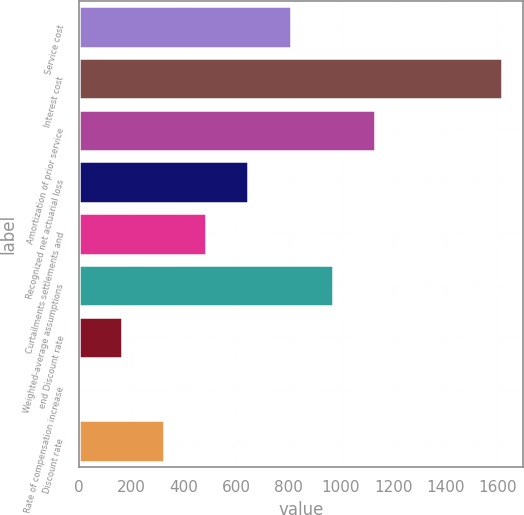<chart> <loc_0><loc_0><loc_500><loc_500><bar_chart><fcel>Service cost<fcel>Interest cost<fcel>Amortization of prior service<fcel>Recognized net actuarial loss<fcel>Curtailments settlements and<fcel>Weighted-average assumptions<fcel>end Discount rate<fcel>Rate of compensation increase<fcel>Discount rate<nl><fcel>808.23<fcel>1615<fcel>1130.93<fcel>646.88<fcel>485.53<fcel>969.58<fcel>162.83<fcel>1.48<fcel>324.18<nl></chart> 